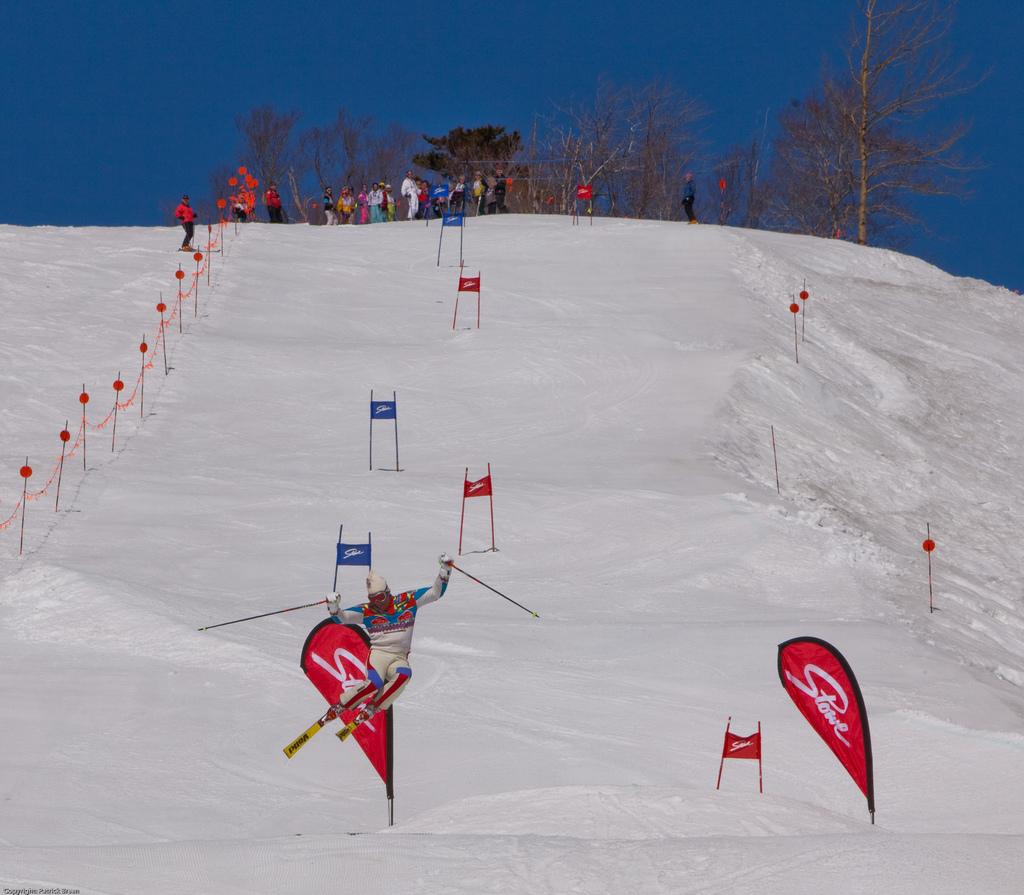What's the red flag state?
Give a very brief answer. Stowe. 